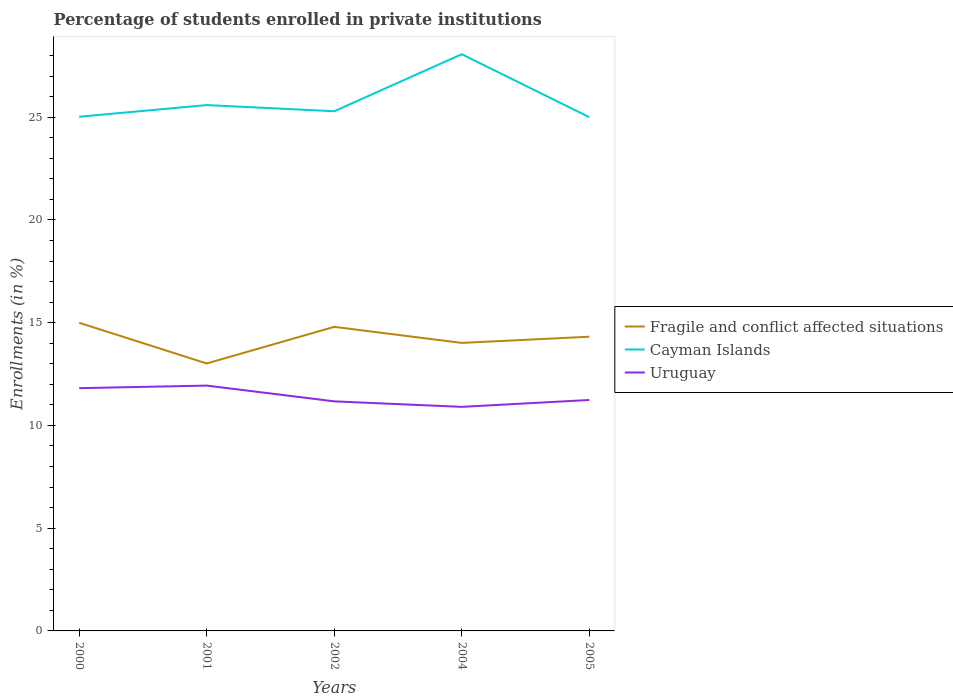Does the line corresponding to Uruguay intersect with the line corresponding to Cayman Islands?
Your answer should be very brief. No. Across all years, what is the maximum percentage of trained teachers in Uruguay?
Ensure brevity in your answer.  10.9. What is the total percentage of trained teachers in Cayman Islands in the graph?
Provide a succinct answer. 0.29. What is the difference between the highest and the second highest percentage of trained teachers in Uruguay?
Offer a terse response. 1.04. What is the difference between the highest and the lowest percentage of trained teachers in Uruguay?
Your answer should be very brief. 2. Is the percentage of trained teachers in Uruguay strictly greater than the percentage of trained teachers in Fragile and conflict affected situations over the years?
Offer a very short reply. Yes. How many years are there in the graph?
Keep it short and to the point. 5. Are the values on the major ticks of Y-axis written in scientific E-notation?
Your answer should be compact. No. How many legend labels are there?
Offer a terse response. 3. What is the title of the graph?
Keep it short and to the point. Percentage of students enrolled in private institutions. What is the label or title of the Y-axis?
Make the answer very short. Enrollments (in %). What is the Enrollments (in %) in Fragile and conflict affected situations in 2000?
Give a very brief answer. 14.99. What is the Enrollments (in %) in Cayman Islands in 2000?
Your response must be concise. 25.02. What is the Enrollments (in %) in Uruguay in 2000?
Give a very brief answer. 11.81. What is the Enrollments (in %) in Fragile and conflict affected situations in 2001?
Provide a succinct answer. 13.01. What is the Enrollments (in %) in Cayman Islands in 2001?
Your response must be concise. 25.59. What is the Enrollments (in %) of Uruguay in 2001?
Provide a short and direct response. 11.94. What is the Enrollments (in %) in Fragile and conflict affected situations in 2002?
Keep it short and to the point. 14.8. What is the Enrollments (in %) of Cayman Islands in 2002?
Your answer should be compact. 25.29. What is the Enrollments (in %) of Uruguay in 2002?
Give a very brief answer. 11.17. What is the Enrollments (in %) of Fragile and conflict affected situations in 2004?
Provide a succinct answer. 14.02. What is the Enrollments (in %) of Cayman Islands in 2004?
Make the answer very short. 28.06. What is the Enrollments (in %) of Uruguay in 2004?
Provide a succinct answer. 10.9. What is the Enrollments (in %) of Fragile and conflict affected situations in 2005?
Your answer should be compact. 14.32. What is the Enrollments (in %) of Cayman Islands in 2005?
Make the answer very short. 25. What is the Enrollments (in %) of Uruguay in 2005?
Ensure brevity in your answer.  11.24. Across all years, what is the maximum Enrollments (in %) in Fragile and conflict affected situations?
Offer a terse response. 14.99. Across all years, what is the maximum Enrollments (in %) of Cayman Islands?
Ensure brevity in your answer.  28.06. Across all years, what is the maximum Enrollments (in %) of Uruguay?
Offer a very short reply. 11.94. Across all years, what is the minimum Enrollments (in %) in Fragile and conflict affected situations?
Your answer should be very brief. 13.01. Across all years, what is the minimum Enrollments (in %) in Uruguay?
Give a very brief answer. 10.9. What is the total Enrollments (in %) in Fragile and conflict affected situations in the graph?
Your answer should be compact. 71.14. What is the total Enrollments (in %) in Cayman Islands in the graph?
Offer a very short reply. 128.96. What is the total Enrollments (in %) in Uruguay in the graph?
Give a very brief answer. 57.06. What is the difference between the Enrollments (in %) in Fragile and conflict affected situations in 2000 and that in 2001?
Make the answer very short. 1.98. What is the difference between the Enrollments (in %) of Cayman Islands in 2000 and that in 2001?
Give a very brief answer. -0.57. What is the difference between the Enrollments (in %) in Uruguay in 2000 and that in 2001?
Your answer should be very brief. -0.12. What is the difference between the Enrollments (in %) in Fragile and conflict affected situations in 2000 and that in 2002?
Ensure brevity in your answer.  0.2. What is the difference between the Enrollments (in %) of Cayman Islands in 2000 and that in 2002?
Your response must be concise. -0.27. What is the difference between the Enrollments (in %) in Uruguay in 2000 and that in 2002?
Offer a very short reply. 0.64. What is the difference between the Enrollments (in %) of Fragile and conflict affected situations in 2000 and that in 2004?
Your answer should be compact. 0.98. What is the difference between the Enrollments (in %) of Cayman Islands in 2000 and that in 2004?
Give a very brief answer. -3.04. What is the difference between the Enrollments (in %) of Uruguay in 2000 and that in 2004?
Make the answer very short. 0.91. What is the difference between the Enrollments (in %) in Fragile and conflict affected situations in 2000 and that in 2005?
Keep it short and to the point. 0.68. What is the difference between the Enrollments (in %) in Cayman Islands in 2000 and that in 2005?
Offer a very short reply. 0.02. What is the difference between the Enrollments (in %) in Uruguay in 2000 and that in 2005?
Make the answer very short. 0.58. What is the difference between the Enrollments (in %) in Fragile and conflict affected situations in 2001 and that in 2002?
Offer a very short reply. -1.78. What is the difference between the Enrollments (in %) in Uruguay in 2001 and that in 2002?
Offer a very short reply. 0.77. What is the difference between the Enrollments (in %) in Fragile and conflict affected situations in 2001 and that in 2004?
Provide a short and direct response. -1. What is the difference between the Enrollments (in %) in Cayman Islands in 2001 and that in 2004?
Keep it short and to the point. -2.48. What is the difference between the Enrollments (in %) of Uruguay in 2001 and that in 2004?
Provide a succinct answer. 1.03. What is the difference between the Enrollments (in %) in Fragile and conflict affected situations in 2001 and that in 2005?
Offer a terse response. -1.3. What is the difference between the Enrollments (in %) in Cayman Islands in 2001 and that in 2005?
Make the answer very short. 0.59. What is the difference between the Enrollments (in %) of Uruguay in 2001 and that in 2005?
Offer a terse response. 0.7. What is the difference between the Enrollments (in %) in Fragile and conflict affected situations in 2002 and that in 2004?
Offer a very short reply. 0.78. What is the difference between the Enrollments (in %) of Cayman Islands in 2002 and that in 2004?
Your answer should be compact. -2.78. What is the difference between the Enrollments (in %) of Uruguay in 2002 and that in 2004?
Give a very brief answer. 0.27. What is the difference between the Enrollments (in %) in Fragile and conflict affected situations in 2002 and that in 2005?
Offer a terse response. 0.48. What is the difference between the Enrollments (in %) in Cayman Islands in 2002 and that in 2005?
Your response must be concise. 0.29. What is the difference between the Enrollments (in %) of Uruguay in 2002 and that in 2005?
Provide a short and direct response. -0.07. What is the difference between the Enrollments (in %) of Fragile and conflict affected situations in 2004 and that in 2005?
Offer a very short reply. -0.3. What is the difference between the Enrollments (in %) in Cayman Islands in 2004 and that in 2005?
Give a very brief answer. 3.06. What is the difference between the Enrollments (in %) of Uruguay in 2004 and that in 2005?
Keep it short and to the point. -0.34. What is the difference between the Enrollments (in %) of Fragile and conflict affected situations in 2000 and the Enrollments (in %) of Cayman Islands in 2001?
Ensure brevity in your answer.  -10.59. What is the difference between the Enrollments (in %) in Fragile and conflict affected situations in 2000 and the Enrollments (in %) in Uruguay in 2001?
Provide a succinct answer. 3.06. What is the difference between the Enrollments (in %) of Cayman Islands in 2000 and the Enrollments (in %) of Uruguay in 2001?
Offer a very short reply. 13.08. What is the difference between the Enrollments (in %) of Fragile and conflict affected situations in 2000 and the Enrollments (in %) of Cayman Islands in 2002?
Your response must be concise. -10.29. What is the difference between the Enrollments (in %) of Fragile and conflict affected situations in 2000 and the Enrollments (in %) of Uruguay in 2002?
Provide a succinct answer. 3.82. What is the difference between the Enrollments (in %) in Cayman Islands in 2000 and the Enrollments (in %) in Uruguay in 2002?
Your answer should be very brief. 13.85. What is the difference between the Enrollments (in %) in Fragile and conflict affected situations in 2000 and the Enrollments (in %) in Cayman Islands in 2004?
Your response must be concise. -13.07. What is the difference between the Enrollments (in %) of Fragile and conflict affected situations in 2000 and the Enrollments (in %) of Uruguay in 2004?
Make the answer very short. 4.09. What is the difference between the Enrollments (in %) of Cayman Islands in 2000 and the Enrollments (in %) of Uruguay in 2004?
Provide a succinct answer. 14.12. What is the difference between the Enrollments (in %) of Fragile and conflict affected situations in 2000 and the Enrollments (in %) of Cayman Islands in 2005?
Offer a terse response. -10.01. What is the difference between the Enrollments (in %) in Fragile and conflict affected situations in 2000 and the Enrollments (in %) in Uruguay in 2005?
Offer a very short reply. 3.76. What is the difference between the Enrollments (in %) of Cayman Islands in 2000 and the Enrollments (in %) of Uruguay in 2005?
Give a very brief answer. 13.78. What is the difference between the Enrollments (in %) of Fragile and conflict affected situations in 2001 and the Enrollments (in %) of Cayman Islands in 2002?
Offer a very short reply. -12.27. What is the difference between the Enrollments (in %) in Fragile and conflict affected situations in 2001 and the Enrollments (in %) in Uruguay in 2002?
Keep it short and to the point. 1.84. What is the difference between the Enrollments (in %) in Cayman Islands in 2001 and the Enrollments (in %) in Uruguay in 2002?
Provide a short and direct response. 14.42. What is the difference between the Enrollments (in %) of Fragile and conflict affected situations in 2001 and the Enrollments (in %) of Cayman Islands in 2004?
Keep it short and to the point. -15.05. What is the difference between the Enrollments (in %) of Fragile and conflict affected situations in 2001 and the Enrollments (in %) of Uruguay in 2004?
Your response must be concise. 2.11. What is the difference between the Enrollments (in %) in Cayman Islands in 2001 and the Enrollments (in %) in Uruguay in 2004?
Offer a very short reply. 14.69. What is the difference between the Enrollments (in %) in Fragile and conflict affected situations in 2001 and the Enrollments (in %) in Cayman Islands in 2005?
Your answer should be very brief. -11.99. What is the difference between the Enrollments (in %) in Fragile and conflict affected situations in 2001 and the Enrollments (in %) in Uruguay in 2005?
Offer a terse response. 1.78. What is the difference between the Enrollments (in %) of Cayman Islands in 2001 and the Enrollments (in %) of Uruguay in 2005?
Provide a short and direct response. 14.35. What is the difference between the Enrollments (in %) in Fragile and conflict affected situations in 2002 and the Enrollments (in %) in Cayman Islands in 2004?
Your answer should be very brief. -13.27. What is the difference between the Enrollments (in %) in Fragile and conflict affected situations in 2002 and the Enrollments (in %) in Uruguay in 2004?
Ensure brevity in your answer.  3.89. What is the difference between the Enrollments (in %) in Cayman Islands in 2002 and the Enrollments (in %) in Uruguay in 2004?
Make the answer very short. 14.39. What is the difference between the Enrollments (in %) of Fragile and conflict affected situations in 2002 and the Enrollments (in %) of Cayman Islands in 2005?
Your answer should be very brief. -10.2. What is the difference between the Enrollments (in %) of Fragile and conflict affected situations in 2002 and the Enrollments (in %) of Uruguay in 2005?
Give a very brief answer. 3.56. What is the difference between the Enrollments (in %) of Cayman Islands in 2002 and the Enrollments (in %) of Uruguay in 2005?
Provide a short and direct response. 14.05. What is the difference between the Enrollments (in %) in Fragile and conflict affected situations in 2004 and the Enrollments (in %) in Cayman Islands in 2005?
Your response must be concise. -10.98. What is the difference between the Enrollments (in %) in Fragile and conflict affected situations in 2004 and the Enrollments (in %) in Uruguay in 2005?
Your response must be concise. 2.78. What is the difference between the Enrollments (in %) of Cayman Islands in 2004 and the Enrollments (in %) of Uruguay in 2005?
Provide a short and direct response. 16.83. What is the average Enrollments (in %) of Fragile and conflict affected situations per year?
Your answer should be compact. 14.23. What is the average Enrollments (in %) in Cayman Islands per year?
Keep it short and to the point. 25.79. What is the average Enrollments (in %) in Uruguay per year?
Your response must be concise. 11.41. In the year 2000, what is the difference between the Enrollments (in %) in Fragile and conflict affected situations and Enrollments (in %) in Cayman Islands?
Give a very brief answer. -10.03. In the year 2000, what is the difference between the Enrollments (in %) of Fragile and conflict affected situations and Enrollments (in %) of Uruguay?
Give a very brief answer. 3.18. In the year 2000, what is the difference between the Enrollments (in %) of Cayman Islands and Enrollments (in %) of Uruguay?
Ensure brevity in your answer.  13.21. In the year 2001, what is the difference between the Enrollments (in %) of Fragile and conflict affected situations and Enrollments (in %) of Cayman Islands?
Your answer should be compact. -12.57. In the year 2001, what is the difference between the Enrollments (in %) in Fragile and conflict affected situations and Enrollments (in %) in Uruguay?
Make the answer very short. 1.08. In the year 2001, what is the difference between the Enrollments (in %) in Cayman Islands and Enrollments (in %) in Uruguay?
Provide a succinct answer. 13.65. In the year 2002, what is the difference between the Enrollments (in %) in Fragile and conflict affected situations and Enrollments (in %) in Cayman Islands?
Ensure brevity in your answer.  -10.49. In the year 2002, what is the difference between the Enrollments (in %) in Fragile and conflict affected situations and Enrollments (in %) in Uruguay?
Give a very brief answer. 3.63. In the year 2002, what is the difference between the Enrollments (in %) in Cayman Islands and Enrollments (in %) in Uruguay?
Make the answer very short. 14.12. In the year 2004, what is the difference between the Enrollments (in %) in Fragile and conflict affected situations and Enrollments (in %) in Cayman Islands?
Provide a short and direct response. -14.05. In the year 2004, what is the difference between the Enrollments (in %) in Fragile and conflict affected situations and Enrollments (in %) in Uruguay?
Provide a short and direct response. 3.11. In the year 2004, what is the difference between the Enrollments (in %) of Cayman Islands and Enrollments (in %) of Uruguay?
Keep it short and to the point. 17.16. In the year 2005, what is the difference between the Enrollments (in %) in Fragile and conflict affected situations and Enrollments (in %) in Cayman Islands?
Give a very brief answer. -10.68. In the year 2005, what is the difference between the Enrollments (in %) in Fragile and conflict affected situations and Enrollments (in %) in Uruguay?
Your answer should be compact. 3.08. In the year 2005, what is the difference between the Enrollments (in %) of Cayman Islands and Enrollments (in %) of Uruguay?
Your answer should be very brief. 13.76. What is the ratio of the Enrollments (in %) in Fragile and conflict affected situations in 2000 to that in 2001?
Give a very brief answer. 1.15. What is the ratio of the Enrollments (in %) of Cayman Islands in 2000 to that in 2001?
Your answer should be very brief. 0.98. What is the ratio of the Enrollments (in %) in Fragile and conflict affected situations in 2000 to that in 2002?
Your answer should be compact. 1.01. What is the ratio of the Enrollments (in %) in Cayman Islands in 2000 to that in 2002?
Your response must be concise. 0.99. What is the ratio of the Enrollments (in %) in Uruguay in 2000 to that in 2002?
Your answer should be compact. 1.06. What is the ratio of the Enrollments (in %) of Fragile and conflict affected situations in 2000 to that in 2004?
Your response must be concise. 1.07. What is the ratio of the Enrollments (in %) of Cayman Islands in 2000 to that in 2004?
Offer a terse response. 0.89. What is the ratio of the Enrollments (in %) of Uruguay in 2000 to that in 2004?
Offer a very short reply. 1.08. What is the ratio of the Enrollments (in %) in Fragile and conflict affected situations in 2000 to that in 2005?
Make the answer very short. 1.05. What is the ratio of the Enrollments (in %) in Cayman Islands in 2000 to that in 2005?
Make the answer very short. 1. What is the ratio of the Enrollments (in %) of Uruguay in 2000 to that in 2005?
Give a very brief answer. 1.05. What is the ratio of the Enrollments (in %) of Fragile and conflict affected situations in 2001 to that in 2002?
Provide a succinct answer. 0.88. What is the ratio of the Enrollments (in %) in Cayman Islands in 2001 to that in 2002?
Provide a short and direct response. 1.01. What is the ratio of the Enrollments (in %) in Uruguay in 2001 to that in 2002?
Offer a very short reply. 1.07. What is the ratio of the Enrollments (in %) of Fragile and conflict affected situations in 2001 to that in 2004?
Your response must be concise. 0.93. What is the ratio of the Enrollments (in %) of Cayman Islands in 2001 to that in 2004?
Provide a succinct answer. 0.91. What is the ratio of the Enrollments (in %) of Uruguay in 2001 to that in 2004?
Provide a short and direct response. 1.09. What is the ratio of the Enrollments (in %) of Cayman Islands in 2001 to that in 2005?
Ensure brevity in your answer.  1.02. What is the ratio of the Enrollments (in %) of Uruguay in 2001 to that in 2005?
Your response must be concise. 1.06. What is the ratio of the Enrollments (in %) of Fragile and conflict affected situations in 2002 to that in 2004?
Make the answer very short. 1.06. What is the ratio of the Enrollments (in %) of Cayman Islands in 2002 to that in 2004?
Your answer should be compact. 0.9. What is the ratio of the Enrollments (in %) in Uruguay in 2002 to that in 2004?
Offer a terse response. 1.02. What is the ratio of the Enrollments (in %) in Fragile and conflict affected situations in 2002 to that in 2005?
Give a very brief answer. 1.03. What is the ratio of the Enrollments (in %) in Cayman Islands in 2002 to that in 2005?
Your response must be concise. 1.01. What is the ratio of the Enrollments (in %) in Fragile and conflict affected situations in 2004 to that in 2005?
Make the answer very short. 0.98. What is the ratio of the Enrollments (in %) in Cayman Islands in 2004 to that in 2005?
Offer a very short reply. 1.12. What is the ratio of the Enrollments (in %) of Uruguay in 2004 to that in 2005?
Your response must be concise. 0.97. What is the difference between the highest and the second highest Enrollments (in %) of Fragile and conflict affected situations?
Your answer should be compact. 0.2. What is the difference between the highest and the second highest Enrollments (in %) in Cayman Islands?
Provide a succinct answer. 2.48. What is the difference between the highest and the second highest Enrollments (in %) of Uruguay?
Your response must be concise. 0.12. What is the difference between the highest and the lowest Enrollments (in %) in Fragile and conflict affected situations?
Provide a short and direct response. 1.98. What is the difference between the highest and the lowest Enrollments (in %) of Cayman Islands?
Your answer should be compact. 3.06. What is the difference between the highest and the lowest Enrollments (in %) in Uruguay?
Keep it short and to the point. 1.03. 